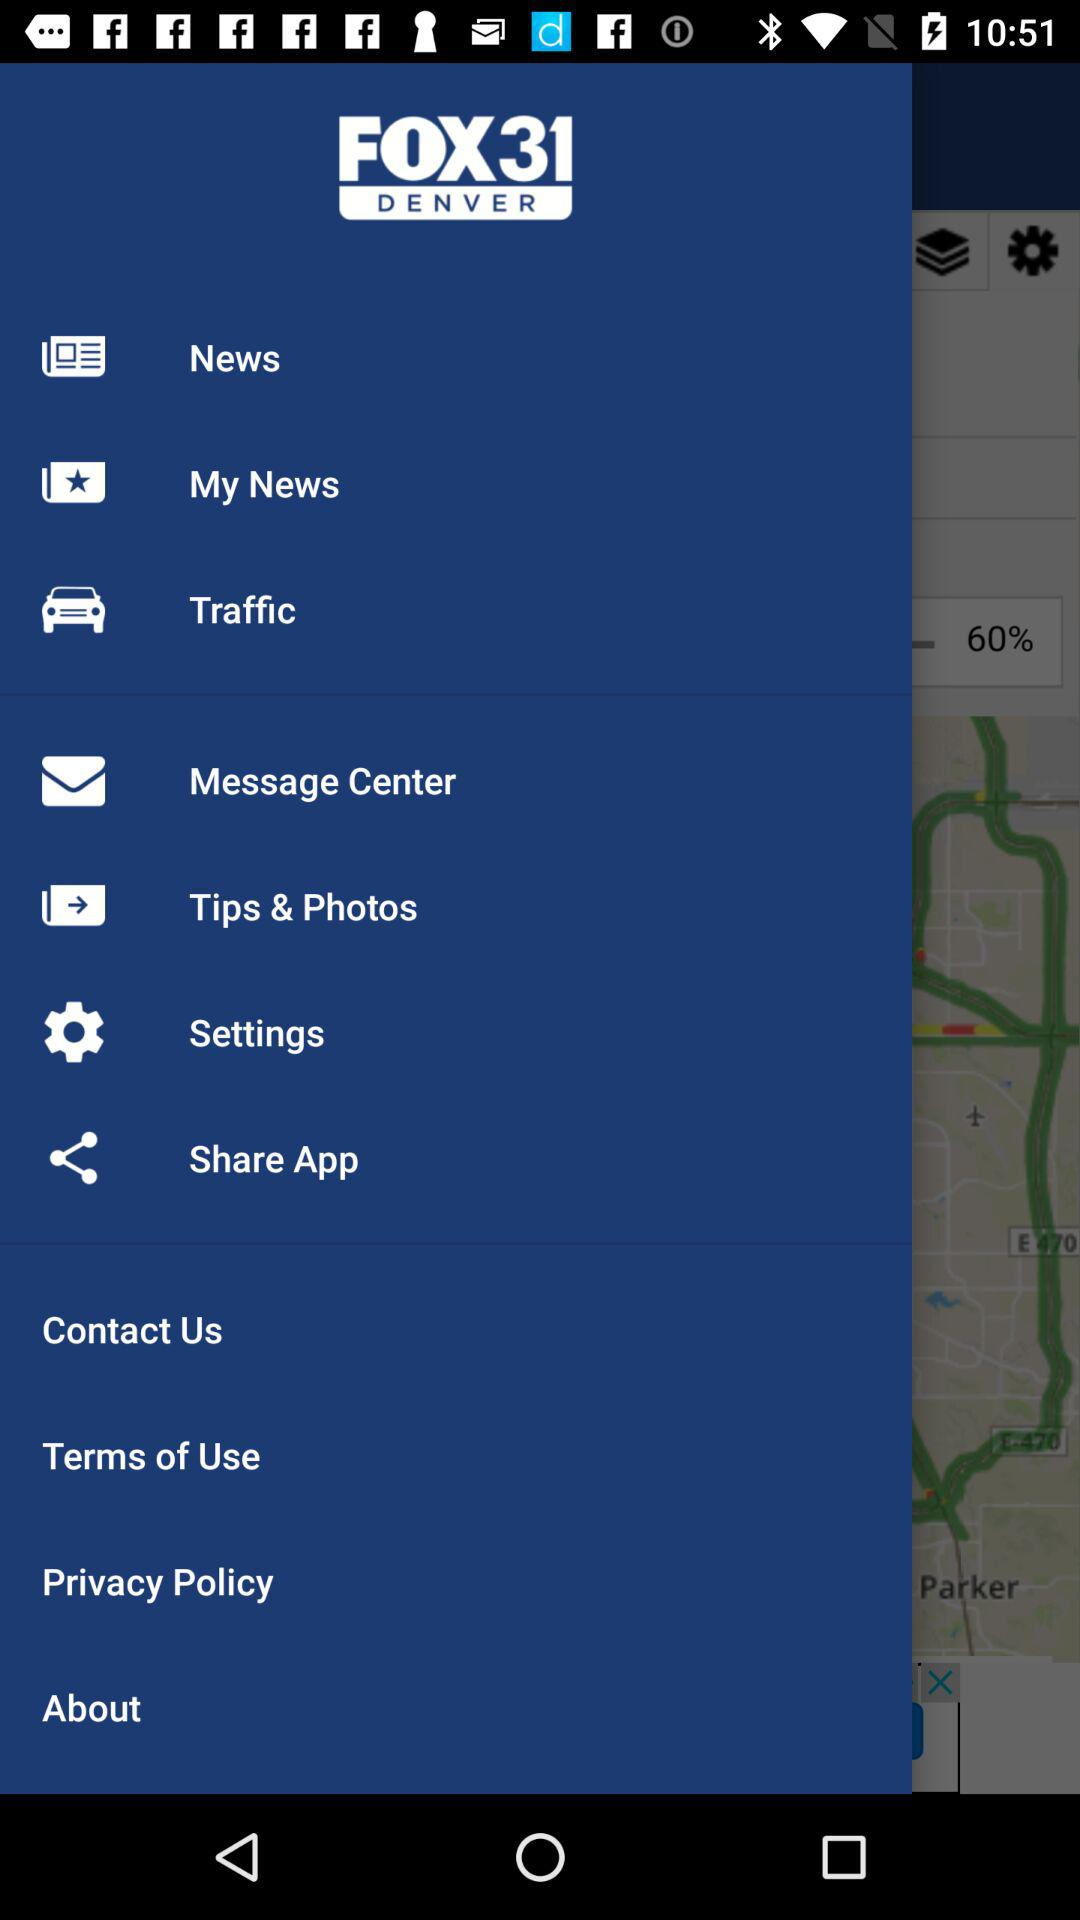What is the application name? The application name is "FOX31 DENVER". 